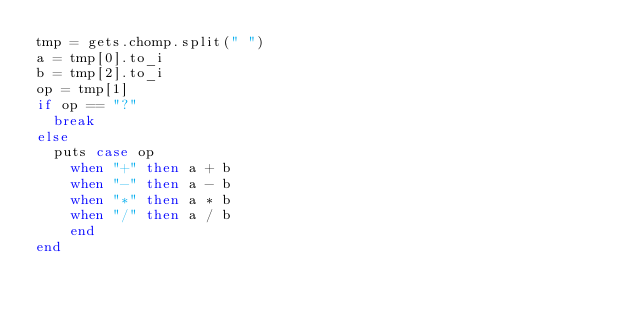Convert code to text. <code><loc_0><loc_0><loc_500><loc_500><_Ruby_>tmp = gets.chomp.split(" ")
a = tmp[0].to_i
b = tmp[2].to_i
op = tmp[1]
if op == "?"
  break
else
  puts case op
    when "+" then a + b
    when "-" then a - b
    when "*" then a * b
    when "/" then a / b
    end
end</code> 